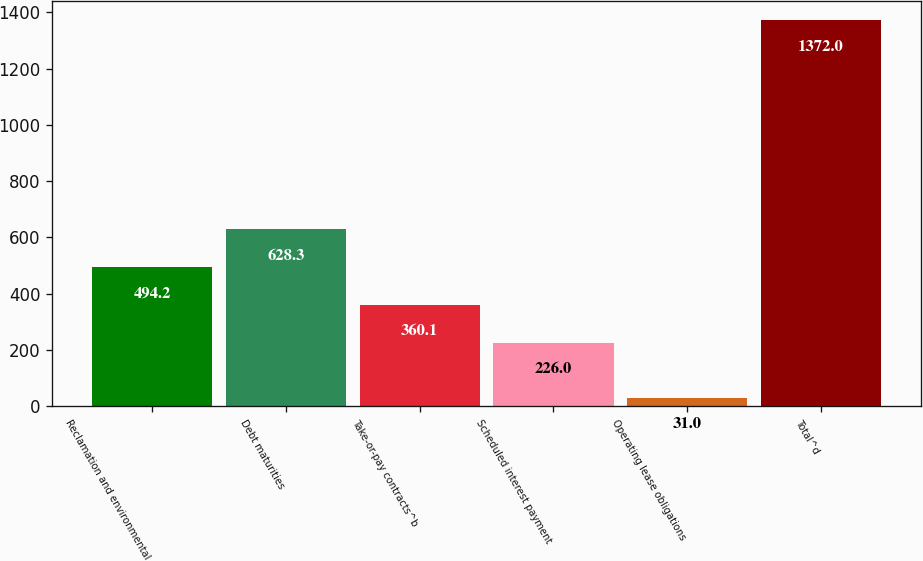Convert chart. <chart><loc_0><loc_0><loc_500><loc_500><bar_chart><fcel>Reclamation and environmental<fcel>Debt maturities<fcel>Take-or-pay contracts^b<fcel>Scheduled interest payment<fcel>Operating lease obligations<fcel>Total^d<nl><fcel>494.2<fcel>628.3<fcel>360.1<fcel>226<fcel>31<fcel>1372<nl></chart> 